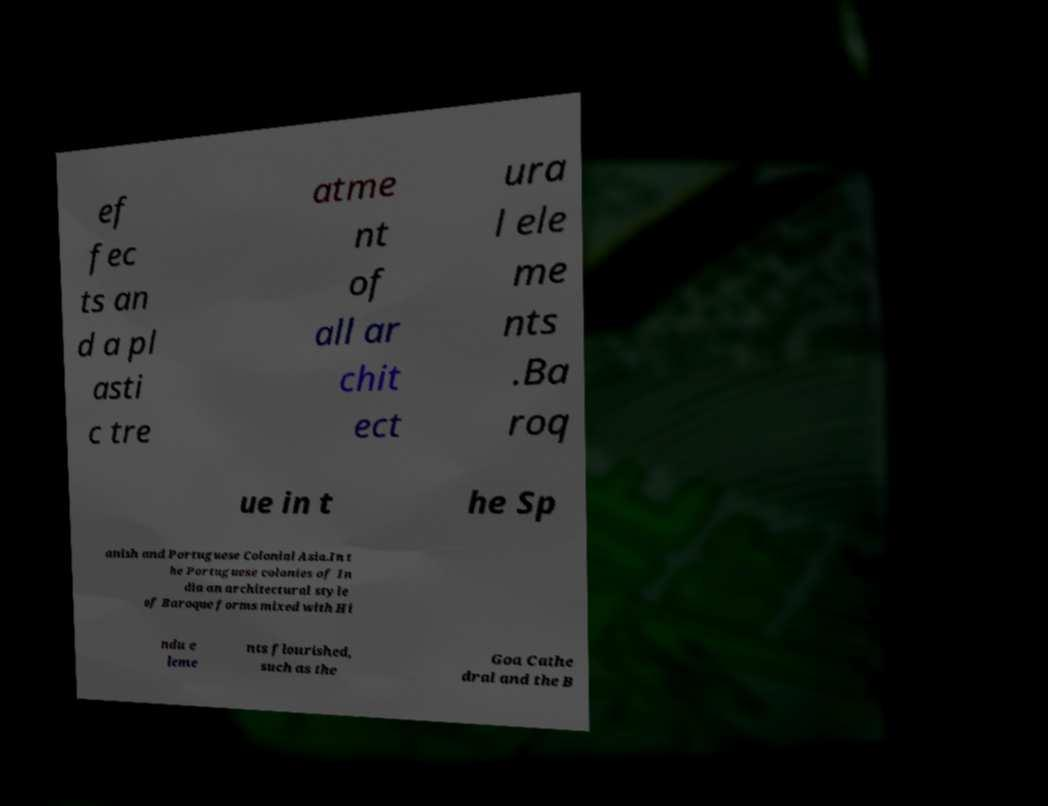What messages or text are displayed in this image? I need them in a readable, typed format. ef fec ts an d a pl asti c tre atme nt of all ar chit ect ura l ele me nts .Ba roq ue in t he Sp anish and Portuguese Colonial Asia.In t he Portuguese colonies of In dia an architectural style of Baroque forms mixed with Hi ndu e leme nts flourished, such as the Goa Cathe dral and the B 